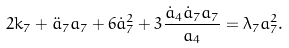<formula> <loc_0><loc_0><loc_500><loc_500>2 k _ { 7 } + { \ddot { a } } _ { 7 } a _ { 7 } + 6 { \dot { a } } ^ { 2 } _ { 7 } + 3 \frac { { \dot { a } } _ { 4 } { \dot { a } } _ { 7 } a _ { 7 } } { a _ { 4 } } = \lambda _ { 7 } a ^ { 2 } _ { 7 } .</formula> 